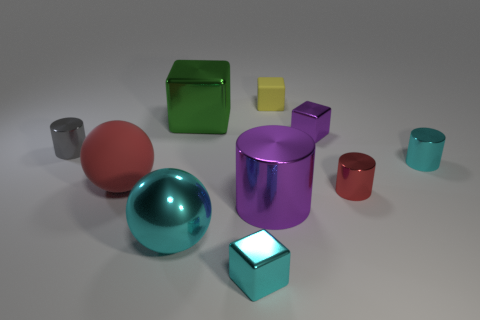Subtract all tiny blocks. How many blocks are left? 1 Subtract all cyan cylinders. How many cylinders are left? 3 Subtract all blocks. How many objects are left? 6 Subtract all brown cylinders. How many cyan cubes are left? 1 Add 4 large green rubber spheres. How many large green rubber spheres exist? 4 Subtract 0 blue cubes. How many objects are left? 10 Subtract 4 cylinders. How many cylinders are left? 0 Subtract all purple cylinders. Subtract all red blocks. How many cylinders are left? 3 Subtract all small yellow matte blocks. Subtract all yellow cubes. How many objects are left? 8 Add 5 small cyan cubes. How many small cyan cubes are left? 6 